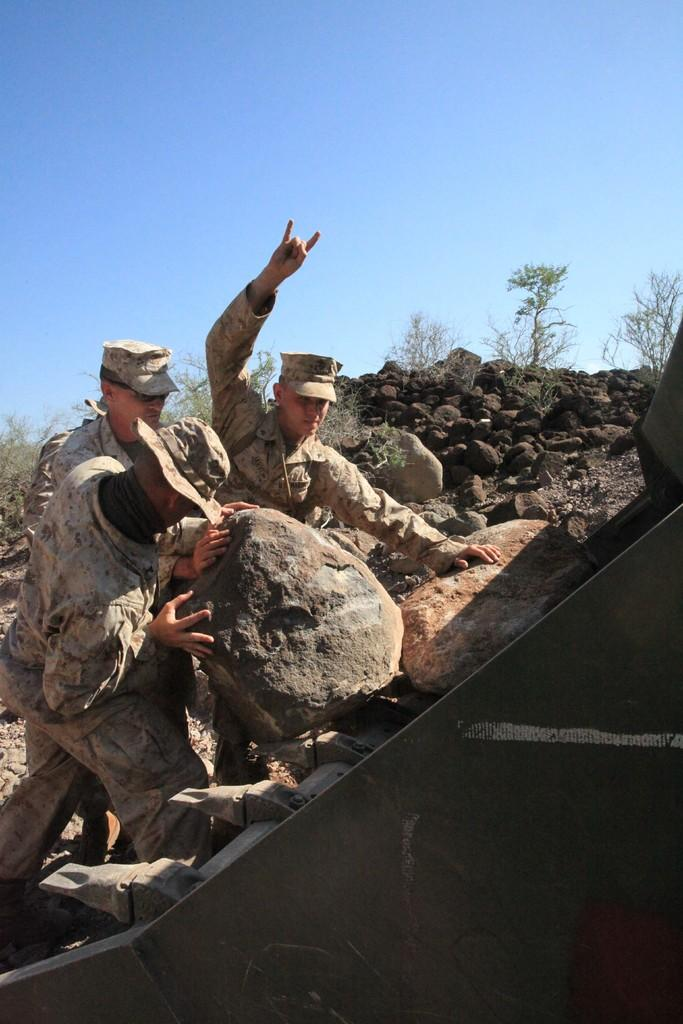How many people are in the image? There are three persons in the image. What are the persons wearing on their heads? The persons are wearing caps. What activity are the persons engaged in? The persons are pushing a rock. What can be seen in the background of the image? There are small plants in the background of the image. What is visible at the top of the image? The sky is visible at the top of the image. What type of net can be seen in the image? There is no net present in the image. How many socks are visible on the persons' feet in the image? The image does not show the persons' feet, so it is not possible to determine if any socks are visible. 